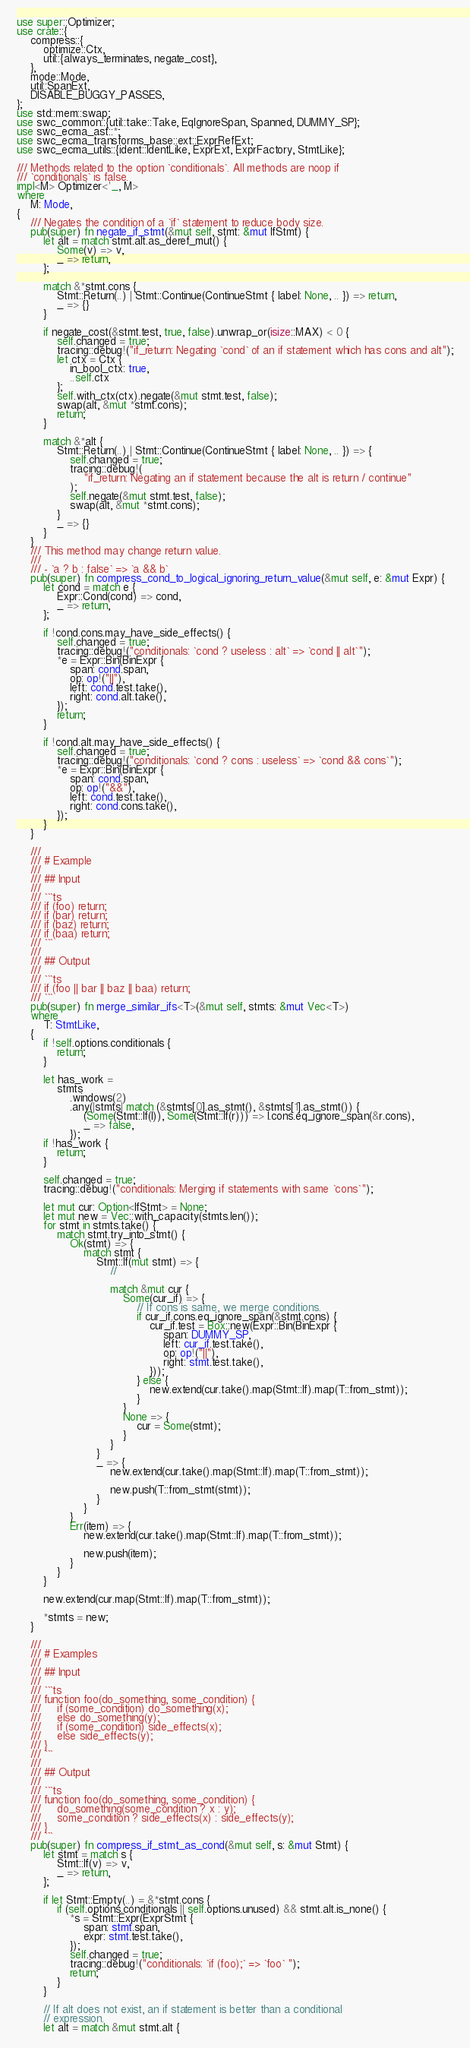Convert code to text. <code><loc_0><loc_0><loc_500><loc_500><_Rust_>use super::Optimizer;
use crate::{
    compress::{
        optimize::Ctx,
        util::{always_terminates, negate_cost},
    },
    mode::Mode,
    util::SpanExt,
    DISABLE_BUGGY_PASSES,
};
use std::mem::swap;
use swc_common::{util::take::Take, EqIgnoreSpan, Spanned, DUMMY_SP};
use swc_ecma_ast::*;
use swc_ecma_transforms_base::ext::ExprRefExt;
use swc_ecma_utils::{ident::IdentLike, ExprExt, ExprFactory, StmtLike};

/// Methods related to the option `conditionals`. All methods are noop if
/// `conditionals` is false.
impl<M> Optimizer<'_, M>
where
    M: Mode,
{
    /// Negates the condition of a `if` statement to reduce body size.
    pub(super) fn negate_if_stmt(&mut self, stmt: &mut IfStmt) {
        let alt = match stmt.alt.as_deref_mut() {
            Some(v) => v,
            _ => return,
        };

        match &*stmt.cons {
            Stmt::Return(..) | Stmt::Continue(ContinueStmt { label: None, .. }) => return,
            _ => {}
        }

        if negate_cost(&stmt.test, true, false).unwrap_or(isize::MAX) < 0 {
            self.changed = true;
            tracing::debug!("if_return: Negating `cond` of an if statement which has cons and alt");
            let ctx = Ctx {
                in_bool_ctx: true,
                ..self.ctx
            };
            self.with_ctx(ctx).negate(&mut stmt.test, false);
            swap(alt, &mut *stmt.cons);
            return;
        }

        match &*alt {
            Stmt::Return(..) | Stmt::Continue(ContinueStmt { label: None, .. }) => {
                self.changed = true;
                tracing::debug!(
                    "if_return: Negating an if statement because the alt is return / continue"
                );
                self.negate(&mut stmt.test, false);
                swap(alt, &mut *stmt.cons);
            }
            _ => {}
        }
    }
    /// This method may change return value.
    ///
    /// - `a ? b : false` => `a && b`
    pub(super) fn compress_cond_to_logical_ignoring_return_value(&mut self, e: &mut Expr) {
        let cond = match e {
            Expr::Cond(cond) => cond,
            _ => return,
        };

        if !cond.cons.may_have_side_effects() {
            self.changed = true;
            tracing::debug!("conditionals: `cond ? useless : alt` => `cond || alt`");
            *e = Expr::Bin(BinExpr {
                span: cond.span,
                op: op!("||"),
                left: cond.test.take(),
                right: cond.alt.take(),
            });
            return;
        }

        if !cond.alt.may_have_side_effects() {
            self.changed = true;
            tracing::debug!("conditionals: `cond ? cons : useless` => `cond && cons`");
            *e = Expr::Bin(BinExpr {
                span: cond.span,
                op: op!("&&"),
                left: cond.test.take(),
                right: cond.cons.take(),
            });
        }
    }

    ///
    /// # Example
    ///
    /// ## Input
    ///
    /// ```ts
    /// if (foo) return;
    /// if (bar) return;
    /// if (baz) return;
    /// if (baa) return;
    /// ```
    ///
    /// ## Output
    ///
    /// ```ts
    /// if (foo || bar || baz || baa) return;
    /// ```
    pub(super) fn merge_similar_ifs<T>(&mut self, stmts: &mut Vec<T>)
    where
        T: StmtLike,
    {
        if !self.options.conditionals {
            return;
        }

        let has_work =
            stmts
                .windows(2)
                .any(|stmts| match (&stmts[0].as_stmt(), &stmts[1].as_stmt()) {
                    (Some(Stmt::If(l)), Some(Stmt::If(r))) => l.cons.eq_ignore_span(&r.cons),
                    _ => false,
                });
        if !has_work {
            return;
        }

        self.changed = true;
        tracing::debug!("conditionals: Merging if statements with same `cons`");

        let mut cur: Option<IfStmt> = None;
        let mut new = Vec::with_capacity(stmts.len());
        for stmt in stmts.take() {
            match stmt.try_into_stmt() {
                Ok(stmt) => {
                    match stmt {
                        Stmt::If(mut stmt) => {
                            //

                            match &mut cur {
                                Some(cur_if) => {
                                    // If cons is same, we merge conditions.
                                    if cur_if.cons.eq_ignore_span(&stmt.cons) {
                                        cur_if.test = Box::new(Expr::Bin(BinExpr {
                                            span: DUMMY_SP,
                                            left: cur_if.test.take(),
                                            op: op!("||"),
                                            right: stmt.test.take(),
                                        }));
                                    } else {
                                        new.extend(cur.take().map(Stmt::If).map(T::from_stmt));
                                    }
                                }
                                None => {
                                    cur = Some(stmt);
                                }
                            }
                        }
                        _ => {
                            new.extend(cur.take().map(Stmt::If).map(T::from_stmt));

                            new.push(T::from_stmt(stmt));
                        }
                    }
                }
                Err(item) => {
                    new.extend(cur.take().map(Stmt::If).map(T::from_stmt));

                    new.push(item);
                }
            }
        }

        new.extend(cur.map(Stmt::If).map(T::from_stmt));

        *stmts = new;
    }

    ///
    /// # Examples
    ///
    /// ## Input
    ///
    /// ```ts
    /// function foo(do_something, some_condition) {
    ///     if (some_condition) do_something(x);
    ///     else do_something(y);
    ///     if (some_condition) side_effects(x);
    ///     else side_effects(y);
    /// }
    /// ```
    ///
    /// ## Output
    ///
    /// ```ts
    /// function foo(do_something, some_condition) {
    ///     do_something(some_condition ? x : y);
    ///     some_condition ? side_effects(x) : side_effects(y);
    /// }
    /// ```
    pub(super) fn compress_if_stmt_as_cond(&mut self, s: &mut Stmt) {
        let stmt = match s {
            Stmt::If(v) => v,
            _ => return,
        };

        if let Stmt::Empty(..) = &*stmt.cons {
            if (self.options.conditionals || self.options.unused) && stmt.alt.is_none() {
                *s = Stmt::Expr(ExprStmt {
                    span: stmt.span,
                    expr: stmt.test.take(),
                });
                self.changed = true;
                tracing::debug!("conditionals: `if (foo);` => `foo` ");
                return;
            }
        }

        // If alt does not exist, an if statement is better than a conditional
        // expression.
        let alt = match &mut stmt.alt {</code> 